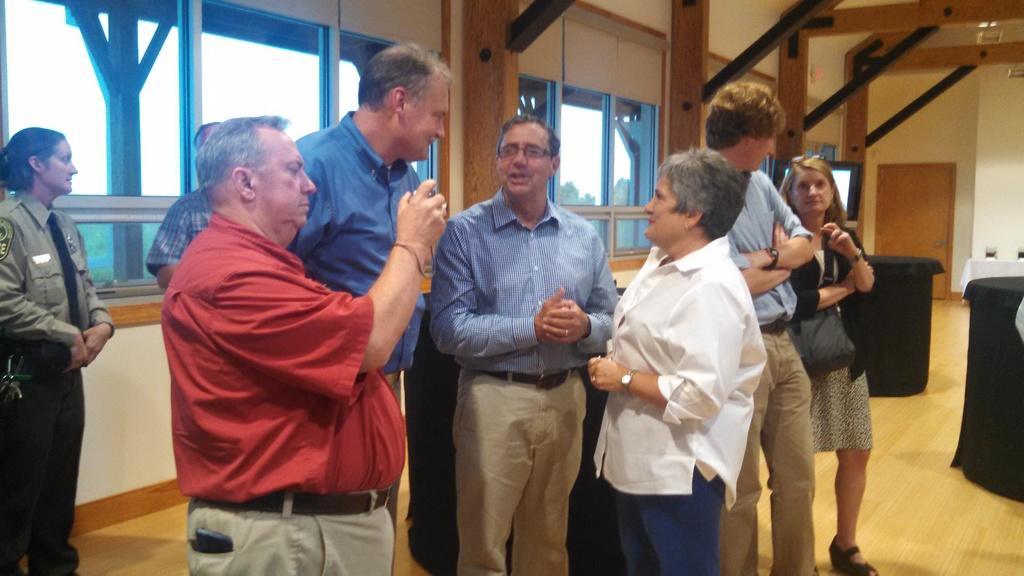Describe this image in one or two sentences. In this image, we can see a group of people are standing on the wooden floor. Here we can see a person is holding some object. Background we can see a wall, glass windows, screen, door. Right side of the image, some tables covered with cloth. Through the glass windows, we can see the outside view. Here there are few trees and sky we can see. 